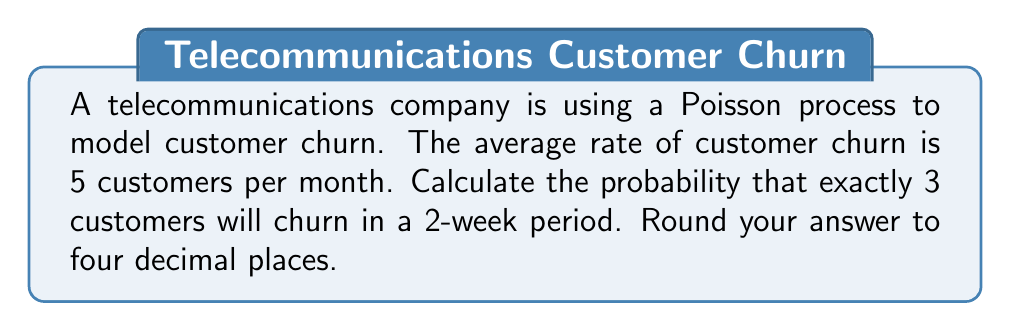Provide a solution to this math problem. Let's approach this step-by-step:

1) First, we need to identify the parameters of our Poisson process:
   - The rate (λ) is 5 customers per month
   - We're interested in a 2-week period, which is half a month

2) We need to adjust our rate for the time period:
   $\lambda_{2 weeks} = 5 * (2/4) = 2.5$ customers per 2 weeks

3) The probability of exactly k events in a Poisson process is given by the formula:

   $P(X = k) = \frac{e^{-\lambda}\lambda^k}{k!}$

   Where:
   - e is Euler's number (approximately 2.71828)
   - λ is the average rate for the time period
   - k is the number of events we're interested in

4) Plugging in our values:
   $P(X = 3) = \frac{e^{-2.5}(2.5)^3}{3!}$

5) Let's calculate this step-by-step:
   - $e^{-2.5} \approx 0.0820$
   - $(2.5)^3 = 15.625$
   - $3! = 6$

   $P(X = 3) = \frac{0.0820 * 15.625}{6} \approx 0.2137$

6) Rounding to four decimal places:
   $P(X = 3) \approx 0.2137$
Answer: 0.2137 